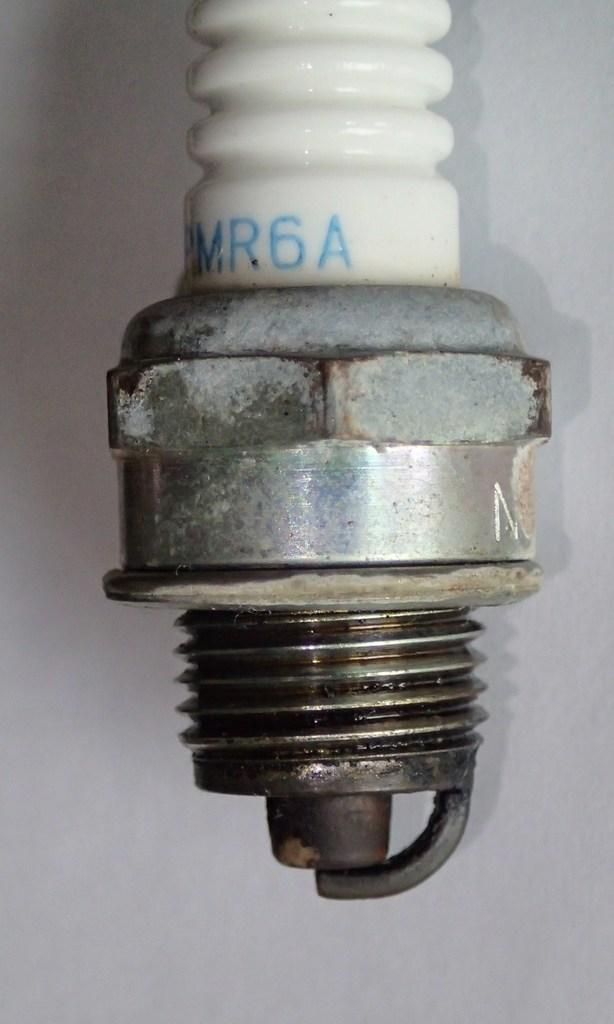What is the main subject of the image? There is an object in the image. Can you describe the colors of the object? The object has white, ash, and black colors. What color is the background of the image? The background of the image is white. How does the object interact with the society in the image? There is no indication of society or interaction in the image; it only features an object with specific colors and a white background. 